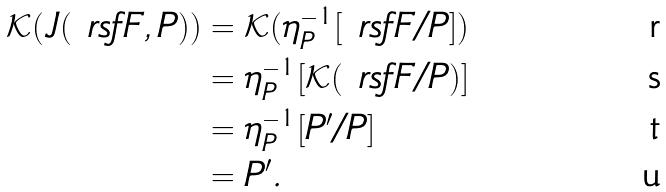Convert formula to latex. <formula><loc_0><loc_0><loc_500><loc_500>\mathcal { K } ( J ( \ r s f F , P ) ) & = \mathcal { K } ( \eta _ { P } ^ { - 1 } [ \ r s f F / P ] ) \\ & = \eta _ { P } ^ { - 1 } [ \mathcal { K } ( \ r s f F / P ) ] \\ & = \eta _ { P } ^ { - 1 } [ P ^ { \prime } / P ] \\ & = P ^ { \prime } .</formula> 